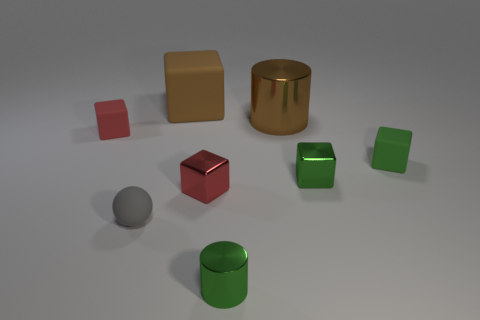There is a brown cylinder that is the same size as the brown matte cube; what material is it?
Your answer should be compact. Metal. What number of other things are there of the same size as the brown cylinder?
Offer a terse response. 1. How many blocks are big blue metallic things or large metal objects?
Make the answer very short. 0. What is the small red block to the right of the matte object in front of the green block to the right of the small green shiny cube made of?
Offer a terse response. Metal. There is another big object that is the same color as the big matte object; what material is it?
Your answer should be compact. Metal. How many other tiny objects are the same material as the gray object?
Provide a short and direct response. 2. There is a cylinder that is behind the rubber sphere; does it have the same size as the brown rubber block?
Your answer should be very brief. Yes. What is the color of the large object that is made of the same material as the small gray sphere?
Offer a terse response. Brown. There is a large block; how many big rubber blocks are to the left of it?
Offer a terse response. 0. There is a large thing that is behind the large brown shiny cylinder; is it the same color as the big thing that is on the right side of the red metallic cube?
Offer a terse response. Yes. 